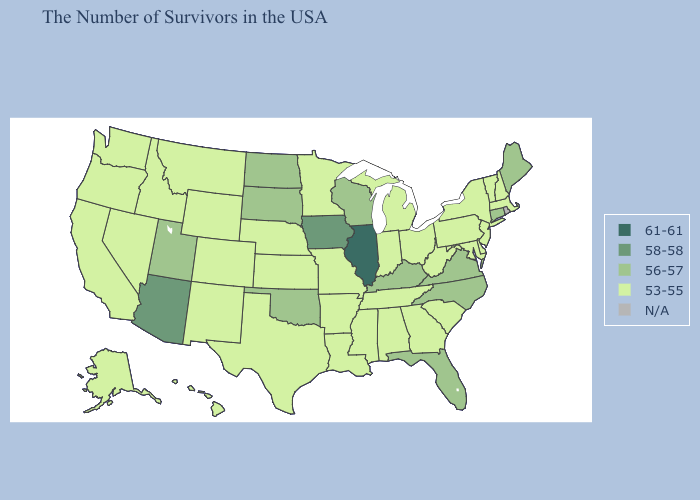Does New Mexico have the highest value in the West?
Quick response, please. No. What is the lowest value in states that border Louisiana?
Give a very brief answer. 53-55. Which states hav the highest value in the South?
Quick response, please. Virginia, North Carolina, Florida, Kentucky, Oklahoma. What is the lowest value in the MidWest?
Quick response, please. 53-55. What is the value of Texas?
Short answer required. 53-55. Which states have the lowest value in the USA?
Short answer required. Massachusetts, New Hampshire, Vermont, New York, New Jersey, Delaware, Maryland, Pennsylvania, South Carolina, West Virginia, Ohio, Georgia, Michigan, Indiana, Alabama, Tennessee, Mississippi, Louisiana, Missouri, Arkansas, Minnesota, Kansas, Nebraska, Texas, Wyoming, Colorado, New Mexico, Montana, Idaho, Nevada, California, Washington, Oregon, Alaska, Hawaii. What is the value of Washington?
Quick response, please. 53-55. What is the value of Wisconsin?
Quick response, please. 56-57. Which states have the lowest value in the USA?
Quick response, please. Massachusetts, New Hampshire, Vermont, New York, New Jersey, Delaware, Maryland, Pennsylvania, South Carolina, West Virginia, Ohio, Georgia, Michigan, Indiana, Alabama, Tennessee, Mississippi, Louisiana, Missouri, Arkansas, Minnesota, Kansas, Nebraska, Texas, Wyoming, Colorado, New Mexico, Montana, Idaho, Nevada, California, Washington, Oregon, Alaska, Hawaii. What is the value of Michigan?
Keep it brief. 53-55. What is the lowest value in states that border Alabama?
Concise answer only. 53-55. What is the highest value in the USA?
Write a very short answer. 61-61. What is the value of Arkansas?
Answer briefly. 53-55. Which states have the lowest value in the USA?
Keep it brief. Massachusetts, New Hampshire, Vermont, New York, New Jersey, Delaware, Maryland, Pennsylvania, South Carolina, West Virginia, Ohio, Georgia, Michigan, Indiana, Alabama, Tennessee, Mississippi, Louisiana, Missouri, Arkansas, Minnesota, Kansas, Nebraska, Texas, Wyoming, Colorado, New Mexico, Montana, Idaho, Nevada, California, Washington, Oregon, Alaska, Hawaii. 